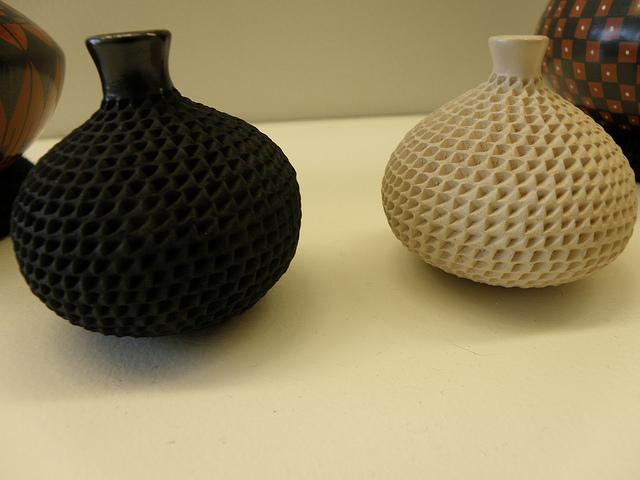Why are the vases colored the colors they are?
Give a very brief answer. Contrast. Are these flower pots?
Quick response, please. No. Are these vases artisan made?
Be succinct. Yes. 